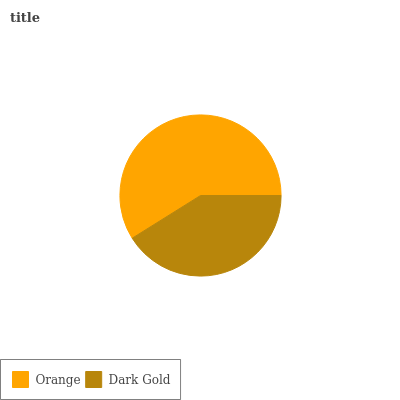Is Dark Gold the minimum?
Answer yes or no. Yes. Is Orange the maximum?
Answer yes or no. Yes. Is Dark Gold the maximum?
Answer yes or no. No. Is Orange greater than Dark Gold?
Answer yes or no. Yes. Is Dark Gold less than Orange?
Answer yes or no. Yes. Is Dark Gold greater than Orange?
Answer yes or no. No. Is Orange less than Dark Gold?
Answer yes or no. No. Is Orange the high median?
Answer yes or no. Yes. Is Dark Gold the low median?
Answer yes or no. Yes. Is Dark Gold the high median?
Answer yes or no. No. Is Orange the low median?
Answer yes or no. No. 